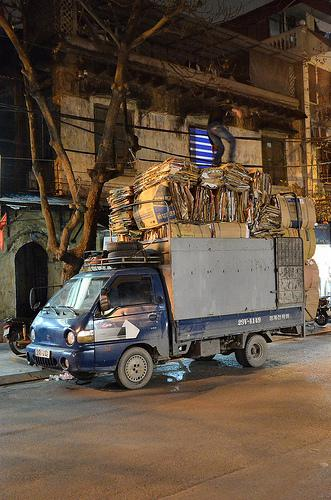Question: when is this taken?
Choices:
A. Morning.
B. Dusk.
C. Daytime.
D. During the evening.
Answer with the letter. Answer: D Question: who is in the picture?
Choices:
A. 1 person`.
B. There is no one pictured.
C. 2 people.
D. 3 men.
Answer with the letter. Answer: B Question: why is the truck not moving?
Choices:
A. It is parked.
B. It has a flat tire.
C. It's out of gas.
D. It's stopped for a train.
Answer with the letter. Answer: A 